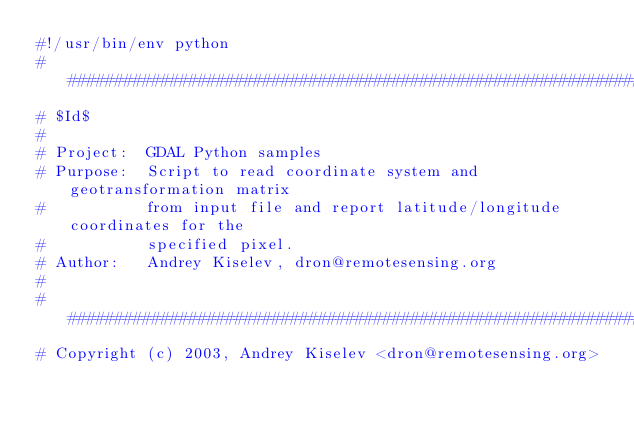Convert code to text. <code><loc_0><loc_0><loc_500><loc_500><_Python_>#!/usr/bin/env python
###############################################################################
# $Id$
#
# Project:  GDAL Python samples
# Purpose:  Script to read coordinate system and geotransformation matrix
#           from input file and report latitude/longitude coordinates for the
#           specified pixel.
# Author:   Andrey Kiselev, dron@remotesensing.org
#
###############################################################################
# Copyright (c) 2003, Andrey Kiselev <dron@remotesensing.org></code> 